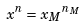Convert formula to latex. <formula><loc_0><loc_0><loc_500><loc_500>x ^ { n } = { x _ { M } } ^ { n _ { M } }</formula> 